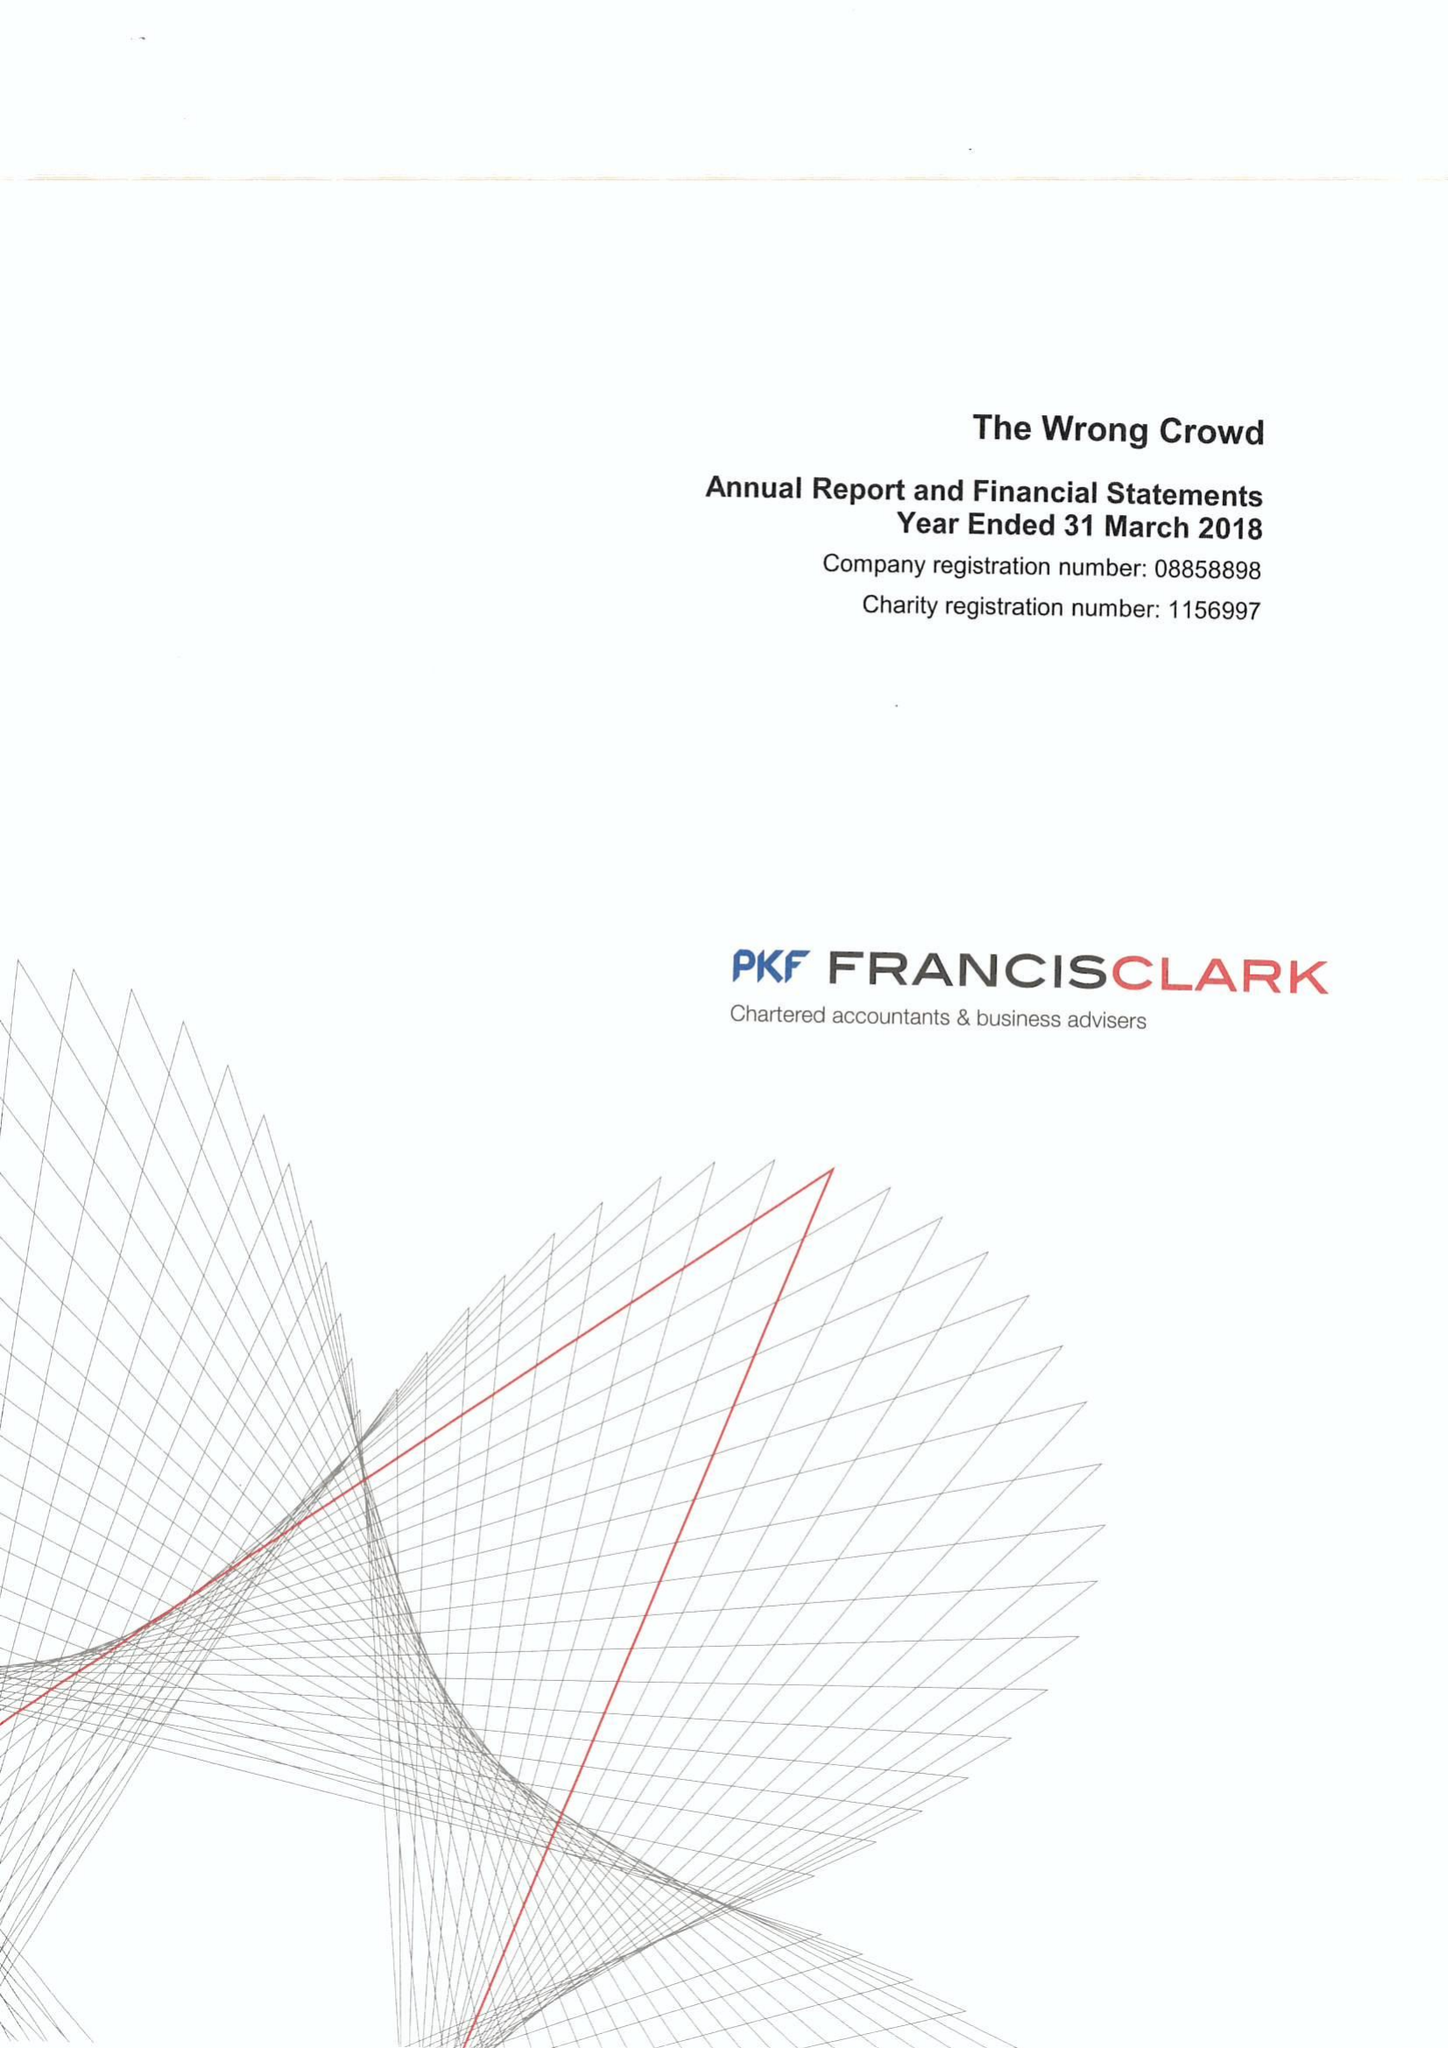What is the value for the charity_number?
Answer the question using a single word or phrase. 1156997 